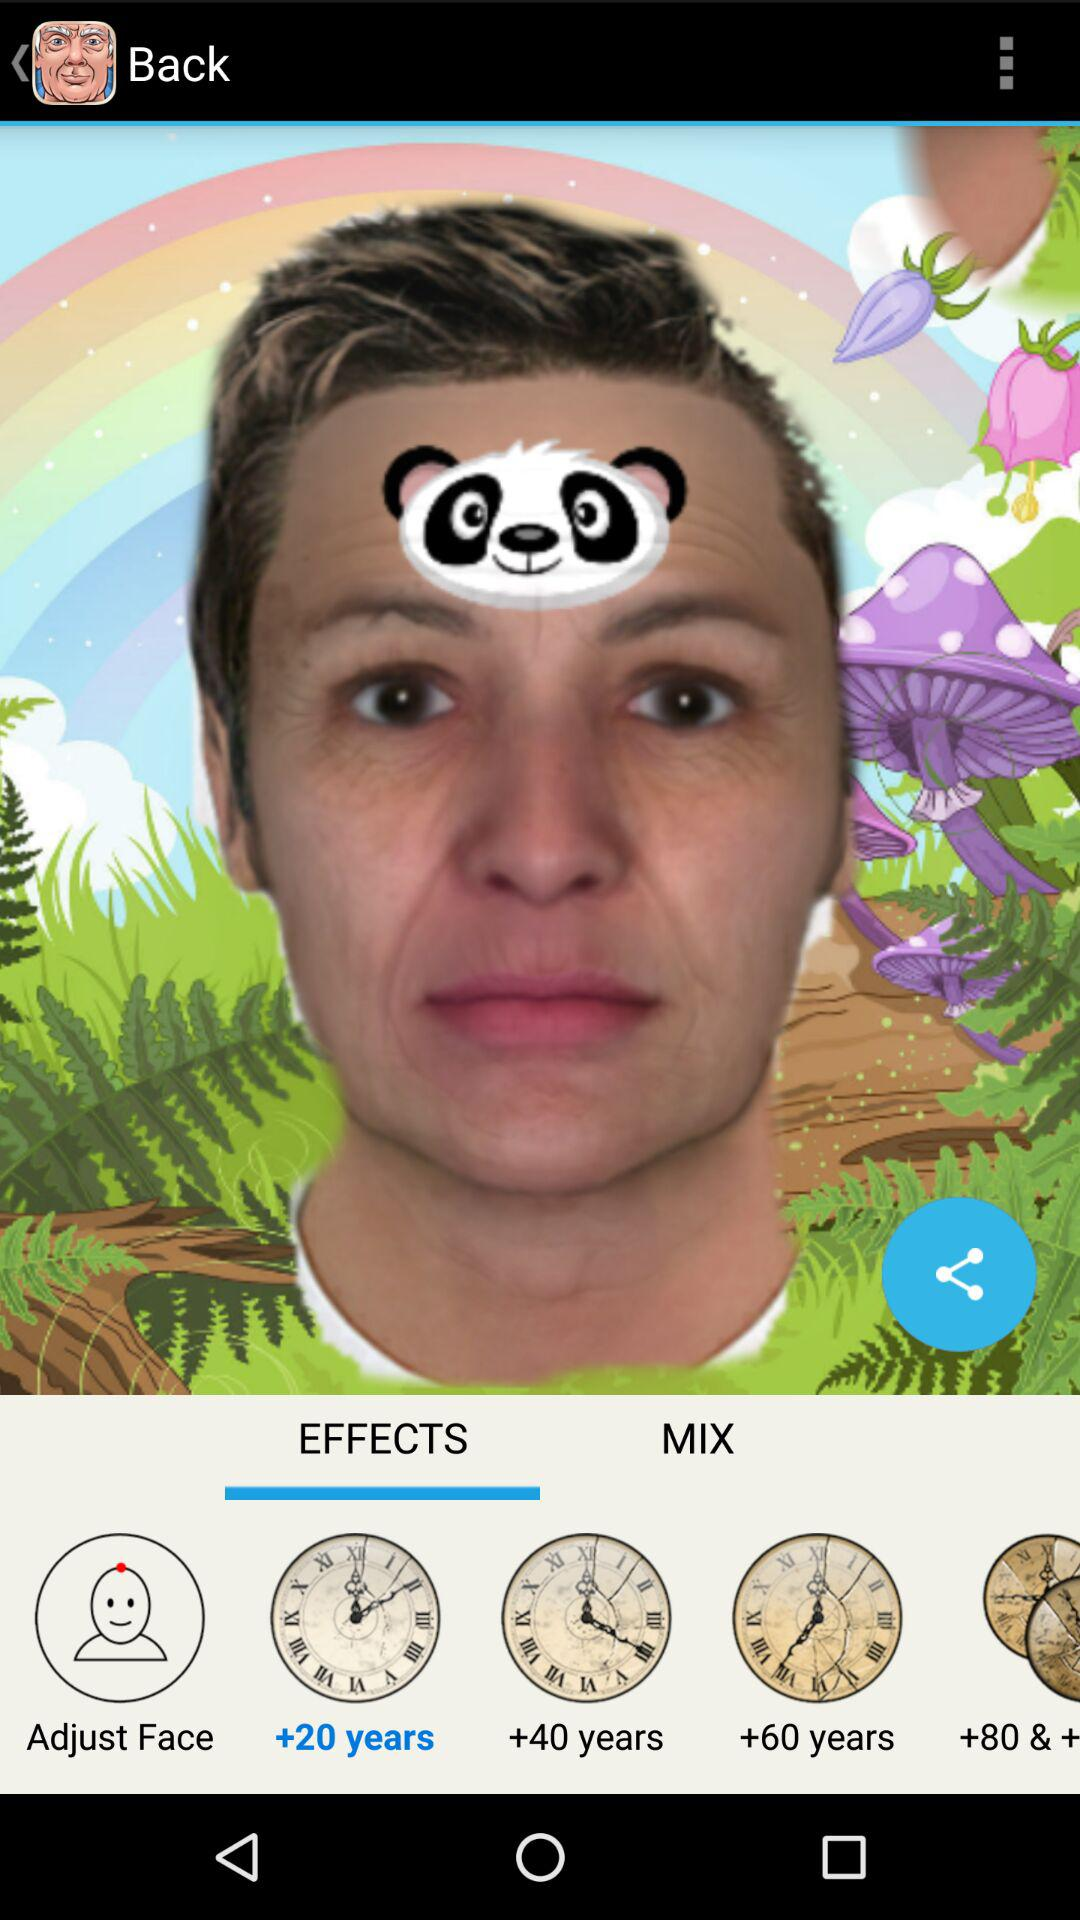Which tab is selected? The selected tab is "EFFECTS". 